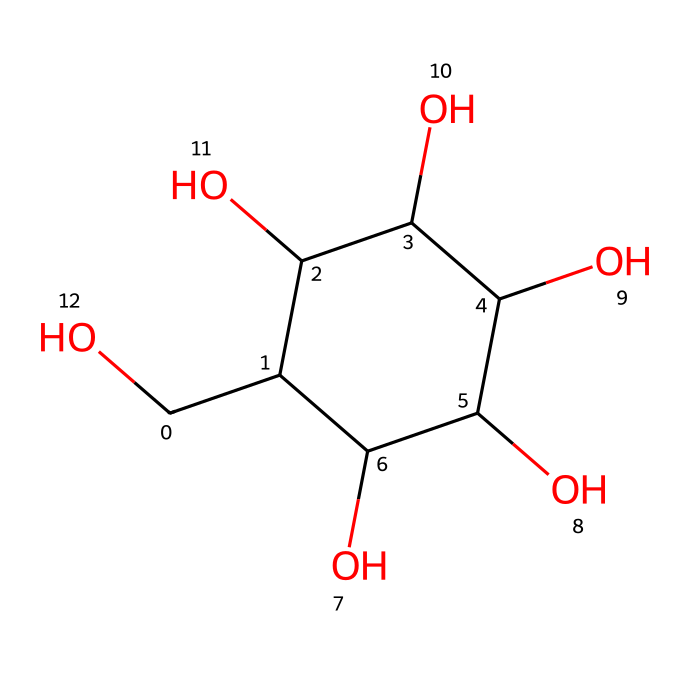What is the name of this chemical? The SMILES representation corresponds to glucose, a common simple sugar.
Answer: glucose How many carbon atoms are present in this molecule? By counting the 'C's in the SMILES representation, we notice six carbon atoms in total.
Answer: 6 What type of bonds are predominantly present in this chemical? The molecule features predominantly single bonds, typical of sugar structures.
Answer: single bonds How many hydroxyl (–OH) groups are in glucose? By identifying the 'O' and 'H' within the structure, we find there are five –OH groups.
Answer: 5 Is glucose a non-electrolyte? Glucose does not ionize in solution, which classifies it as a non-electrolyte.
Answer: yes What functional groups are present in this structure? The main functional groups identified are hydroxyl groups, indicative of alcohol functionalities in sugars.
Answer: hydroxyl groups What is the primary role of glucose in traditional Indian sweets? Glucose serves as a major source of energy, especially in traditional sweets that rely on its sweetness.
Answer: energy source 